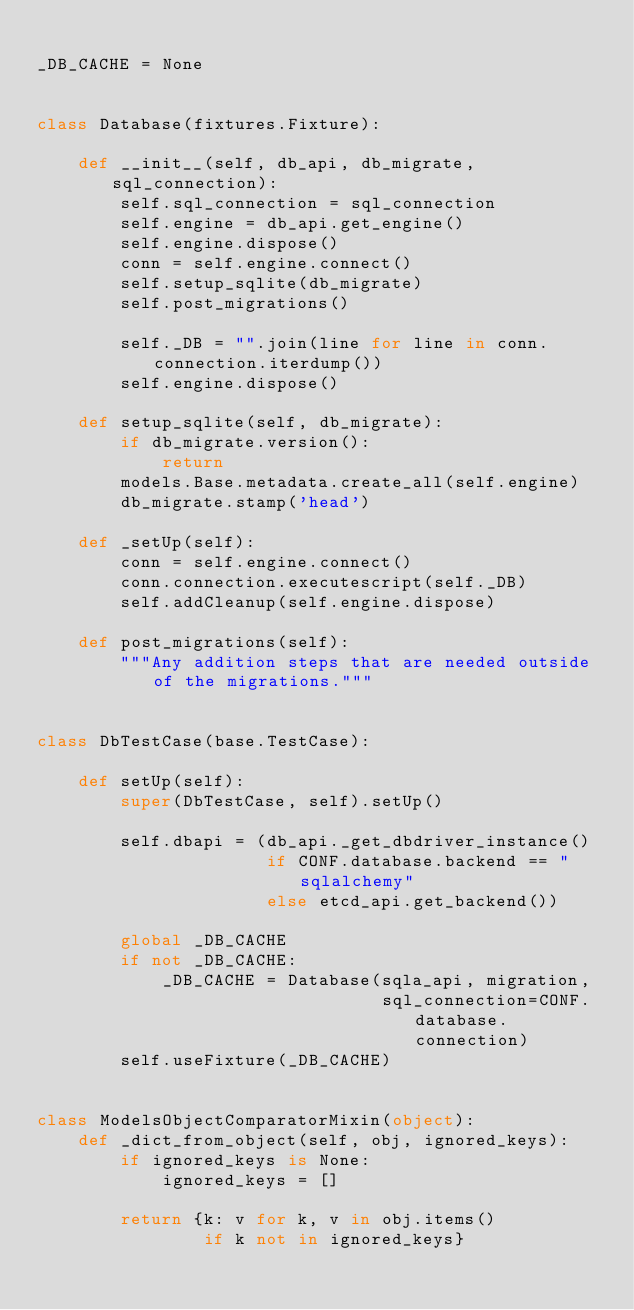<code> <loc_0><loc_0><loc_500><loc_500><_Python_>
_DB_CACHE = None


class Database(fixtures.Fixture):

    def __init__(self, db_api, db_migrate, sql_connection):
        self.sql_connection = sql_connection
        self.engine = db_api.get_engine()
        self.engine.dispose()
        conn = self.engine.connect()
        self.setup_sqlite(db_migrate)
        self.post_migrations()

        self._DB = "".join(line for line in conn.connection.iterdump())
        self.engine.dispose()

    def setup_sqlite(self, db_migrate):
        if db_migrate.version():
            return
        models.Base.metadata.create_all(self.engine)
        db_migrate.stamp('head')

    def _setUp(self):
        conn = self.engine.connect()
        conn.connection.executescript(self._DB)
        self.addCleanup(self.engine.dispose)

    def post_migrations(self):
        """Any addition steps that are needed outside of the migrations."""


class DbTestCase(base.TestCase):

    def setUp(self):
        super(DbTestCase, self).setUp()

        self.dbapi = (db_api._get_dbdriver_instance()
                      if CONF.database.backend == "sqlalchemy"
                      else etcd_api.get_backend())

        global _DB_CACHE
        if not _DB_CACHE:
            _DB_CACHE = Database(sqla_api, migration,
                                 sql_connection=CONF.database.connection)
        self.useFixture(_DB_CACHE)


class ModelsObjectComparatorMixin(object):
    def _dict_from_object(self, obj, ignored_keys):
        if ignored_keys is None:
            ignored_keys = []

        return {k: v for k, v in obj.items()
                if k not in ignored_keys}
</code> 